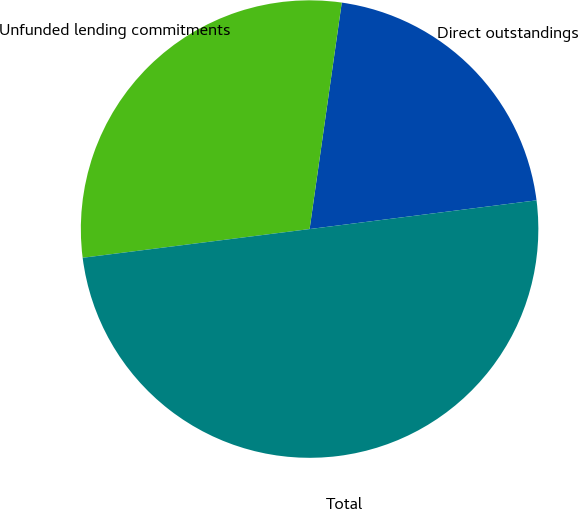Convert chart to OTSL. <chart><loc_0><loc_0><loc_500><loc_500><pie_chart><fcel>Direct outstandings<fcel>Unfunded lending commitments<fcel>Total<nl><fcel>20.75%<fcel>29.25%<fcel>50.0%<nl></chart> 